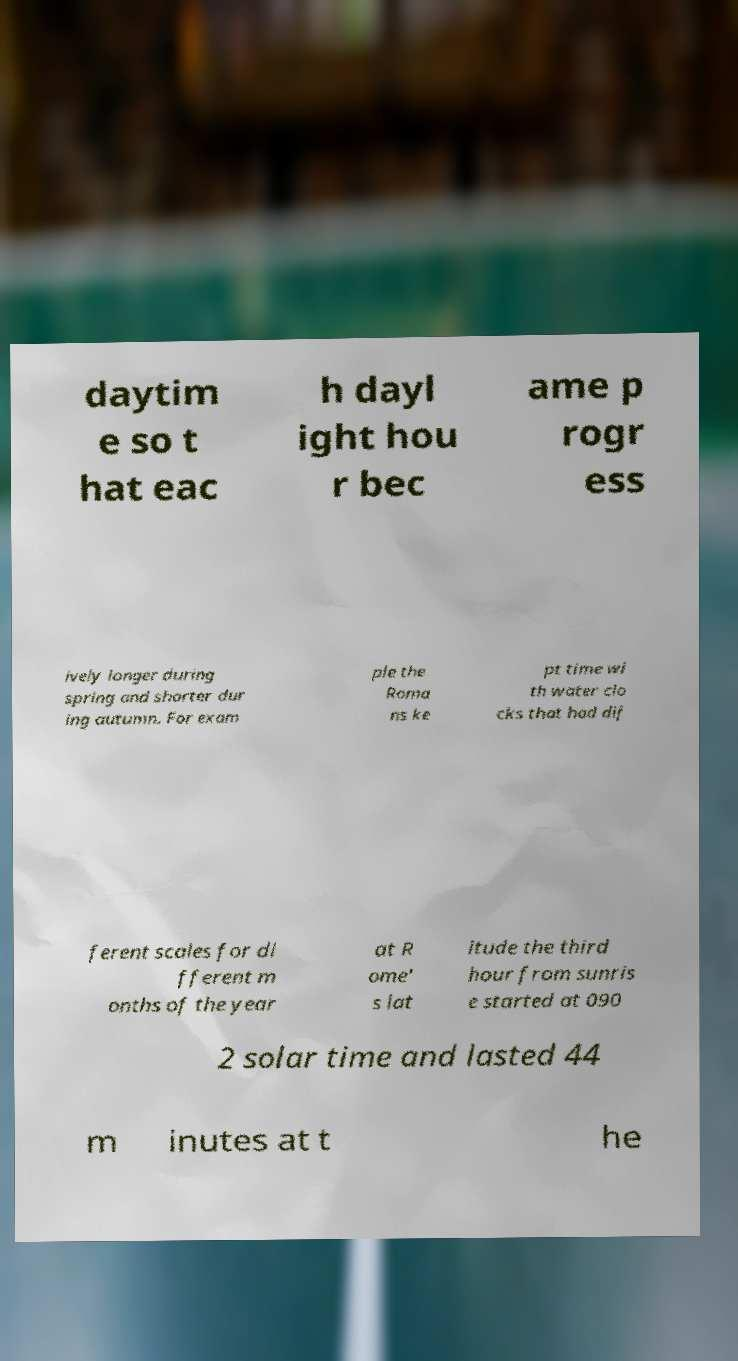There's text embedded in this image that I need extracted. Can you transcribe it verbatim? daytim e so t hat eac h dayl ight hou r bec ame p rogr ess ively longer during spring and shorter dur ing autumn. For exam ple the Roma ns ke pt time wi th water clo cks that had dif ferent scales for di fferent m onths of the year at R ome' s lat itude the third hour from sunris e started at 090 2 solar time and lasted 44 m inutes at t he 